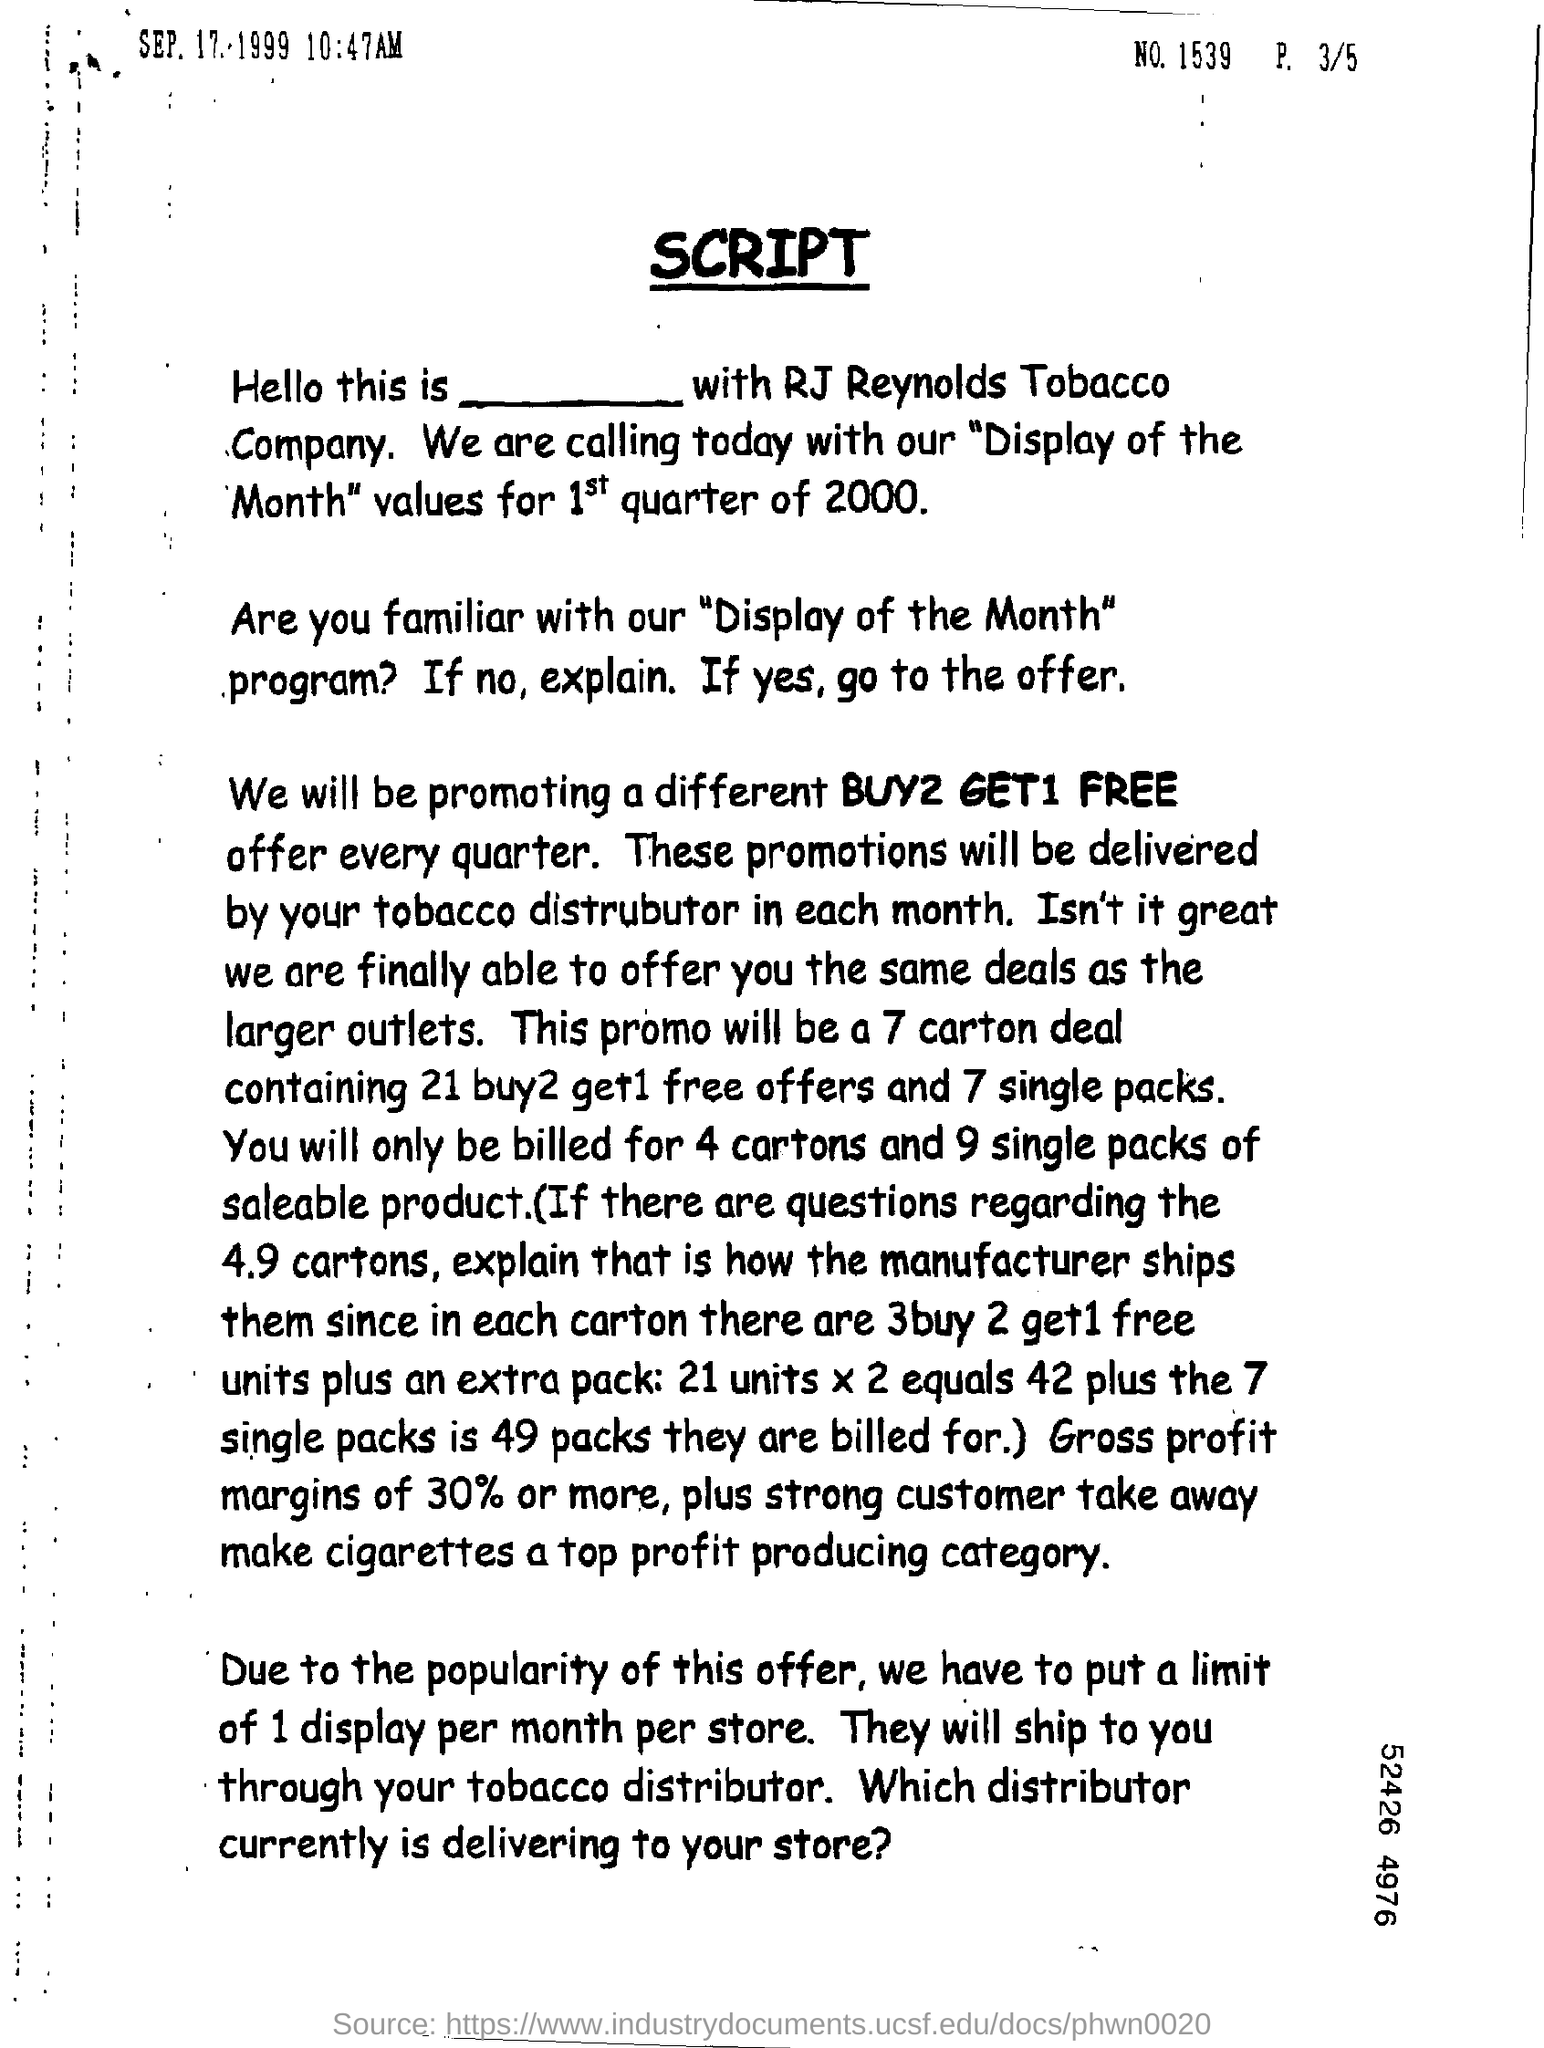Highlight a few significant elements in this photo. The document contains the number 1539. The document provides the date and time of September 17, 1999 at 10:47 AM. 